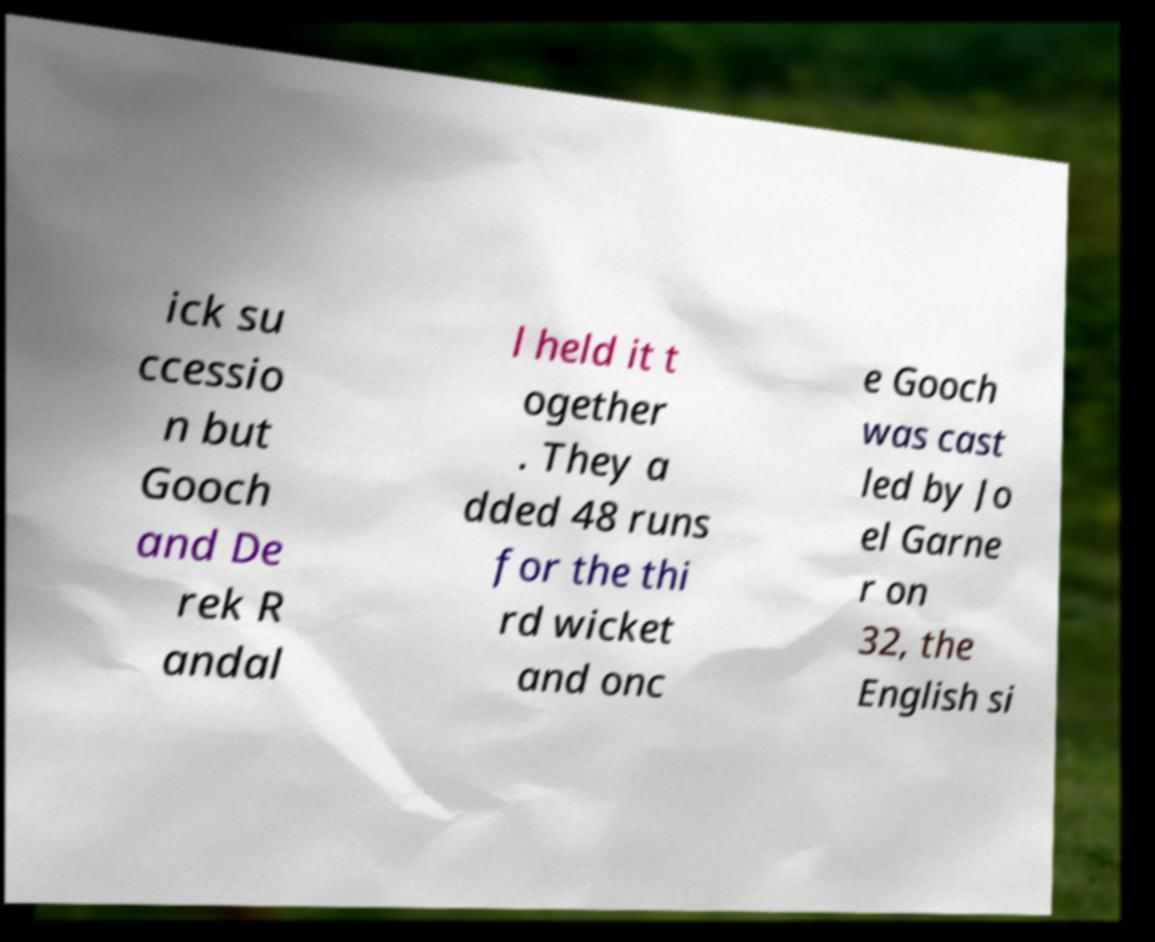For documentation purposes, I need the text within this image transcribed. Could you provide that? ick su ccessio n but Gooch and De rek R andal l held it t ogether . They a dded 48 runs for the thi rd wicket and onc e Gooch was cast led by Jo el Garne r on 32, the English si 